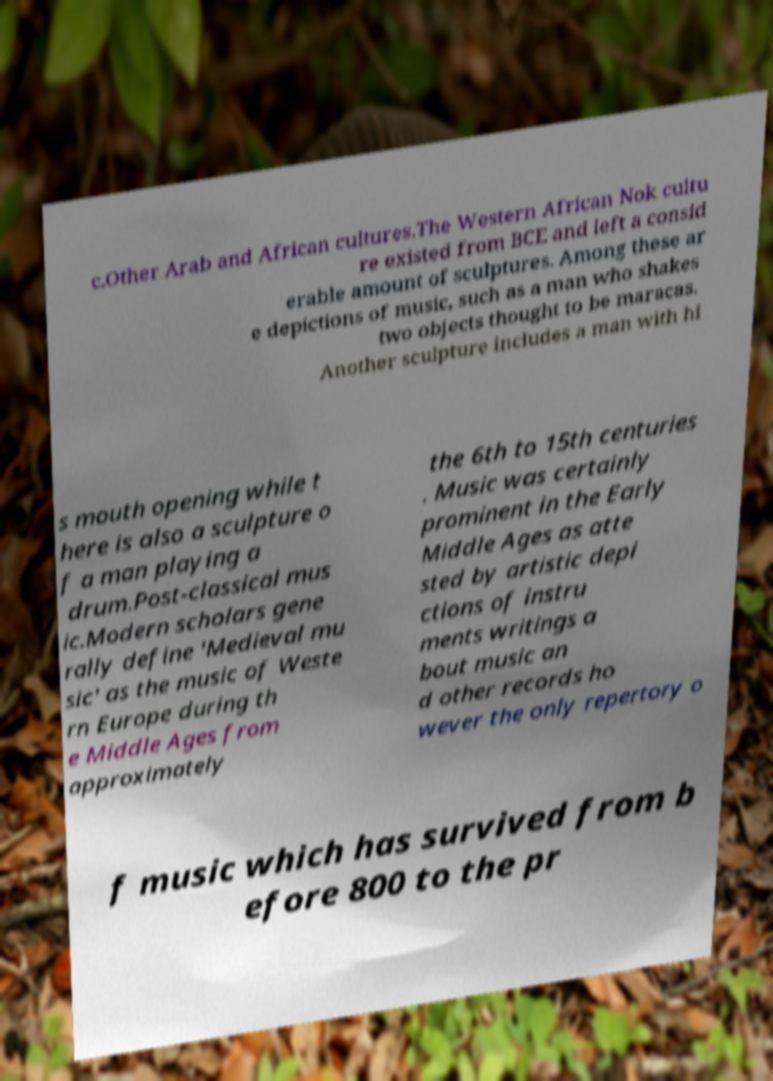Please identify and transcribe the text found in this image. c.Other Arab and African cultures.The Western African Nok cultu re existed from BCE and left a consid erable amount of sculptures. Among these ar e depictions of music, such as a man who shakes two objects thought to be maracas. Another sculpture includes a man with hi s mouth opening while t here is also a sculpture o f a man playing a drum.Post-classical mus ic.Modern scholars gene rally define 'Medieval mu sic' as the music of Weste rn Europe during th e Middle Ages from approximately the 6th to 15th centuries . Music was certainly prominent in the Early Middle Ages as atte sted by artistic depi ctions of instru ments writings a bout music an d other records ho wever the only repertory o f music which has survived from b efore 800 to the pr 